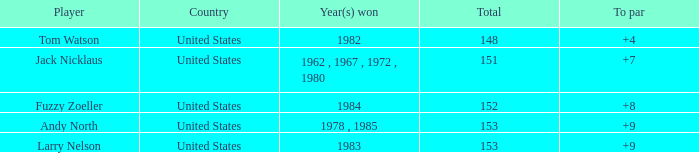What is the Country of the Player with a Total less than 153 and Year(s) won of 1984? United States. 